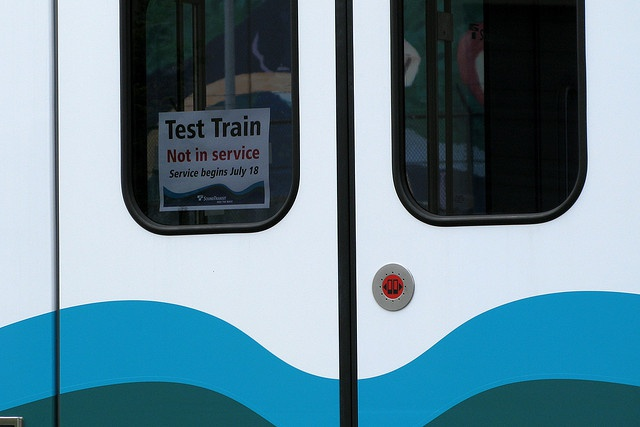Describe the objects in this image and their specific colors. I can see a train in lightgray, black, teal, and gray tones in this image. 